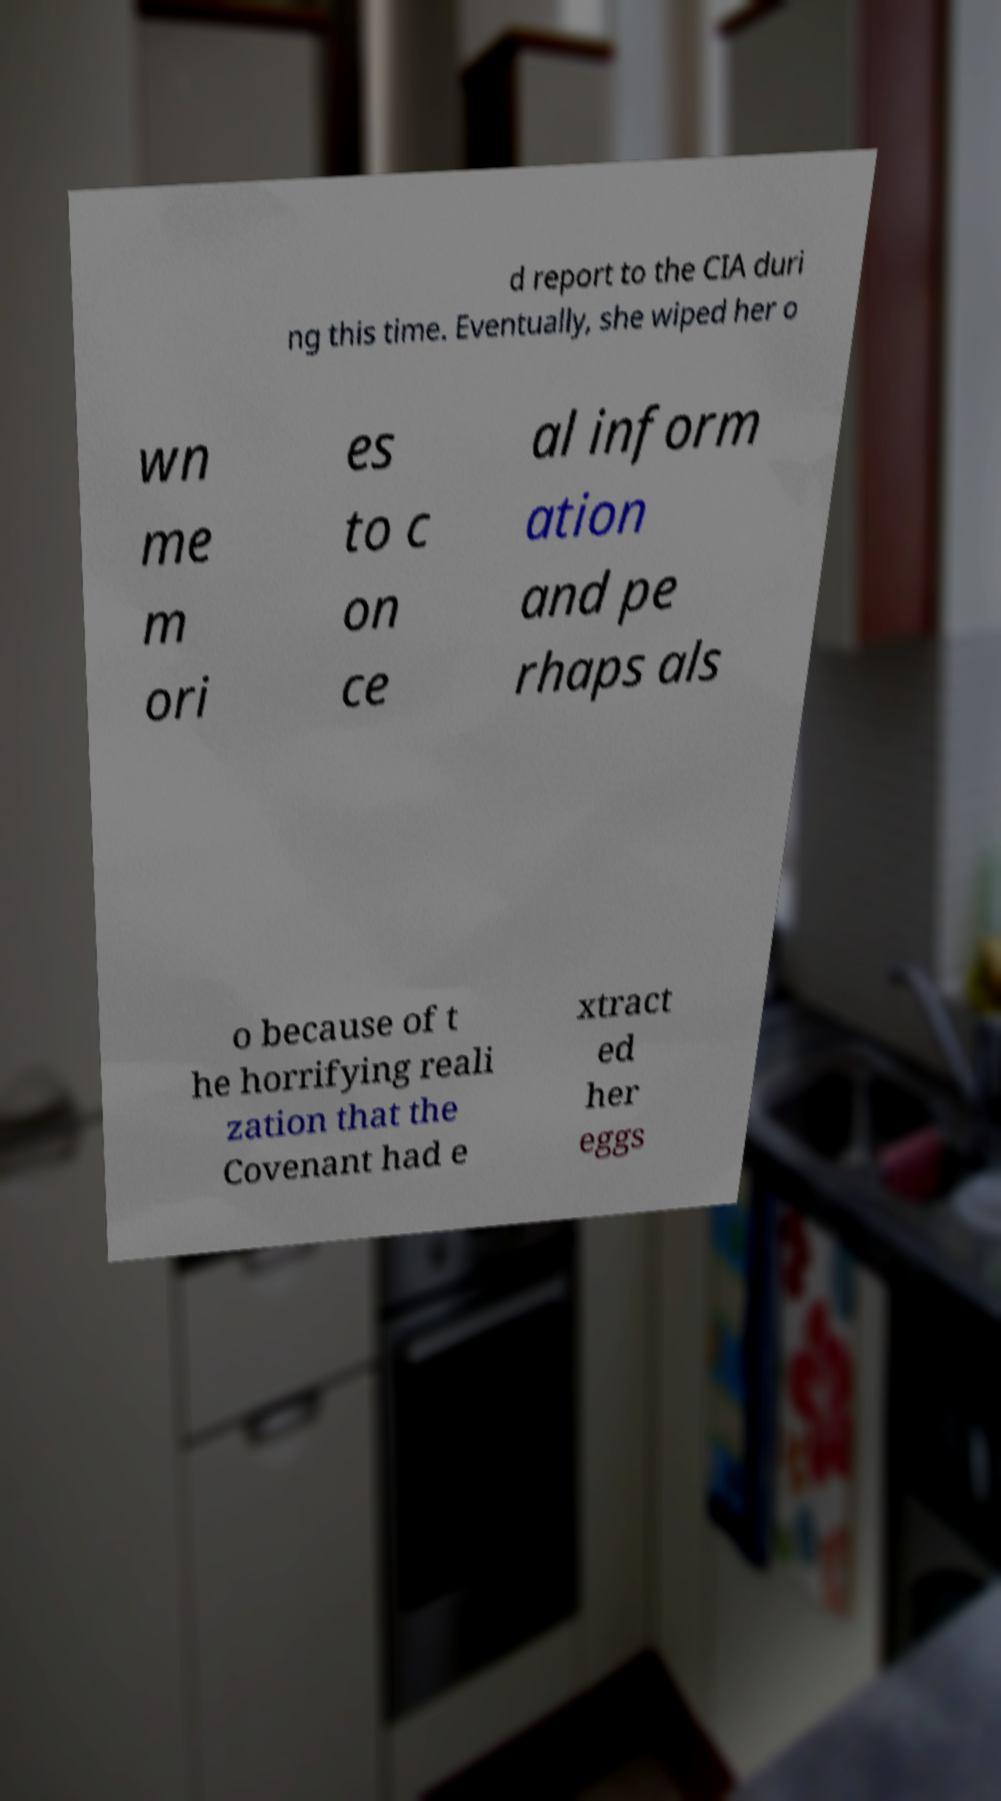Please read and relay the text visible in this image. What does it say? d report to the CIA duri ng this time. Eventually, she wiped her o wn me m ori es to c on ce al inform ation and pe rhaps als o because of t he horrifying reali zation that the Covenant had e xtract ed her eggs 